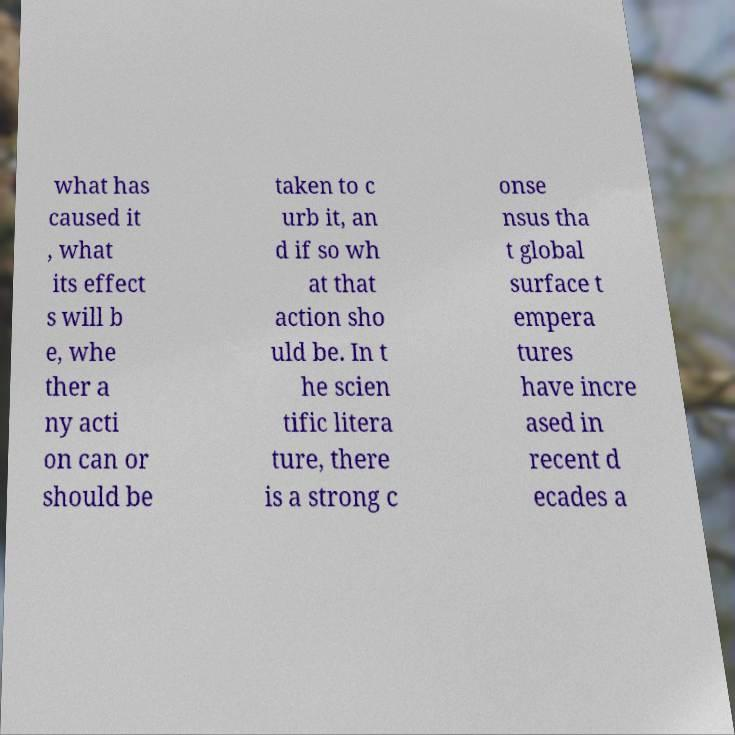Could you assist in decoding the text presented in this image and type it out clearly? what has caused it , what its effect s will b e, whe ther a ny acti on can or should be taken to c urb it, an d if so wh at that action sho uld be. In t he scien tific litera ture, there is a strong c onse nsus tha t global surface t empera tures have incre ased in recent d ecades a 